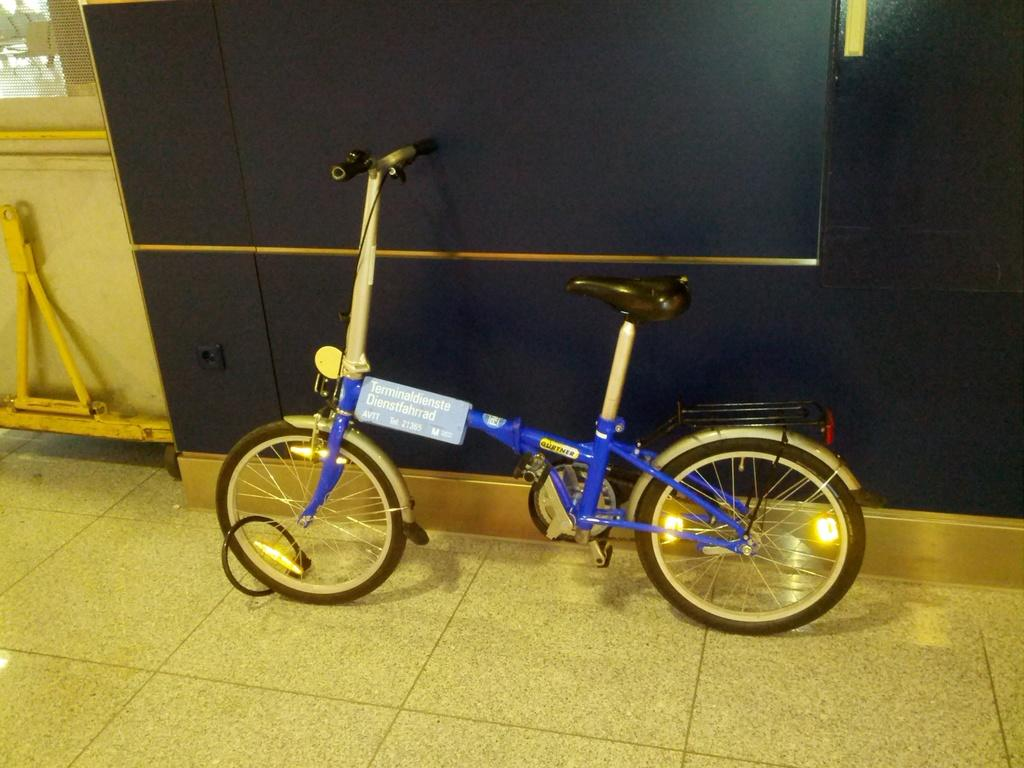What object is on the floor in the image? There is a bicycle on the floor in the image. What can be seen in the background of the image? There is a wall and objects in the background of the image. What type of chalk is being used by the protesters in the image? There are no protesters or chalk present in the image; it features a bicycle on the floor and a wall with objects in the background. 